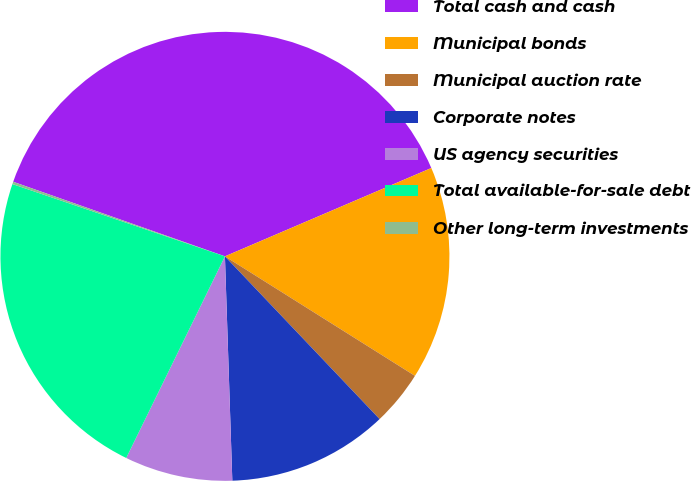Convert chart. <chart><loc_0><loc_0><loc_500><loc_500><pie_chart><fcel>Total cash and cash<fcel>Municipal bonds<fcel>Municipal auction rate<fcel>Corporate notes<fcel>US agency securities<fcel>Total available-for-sale debt<fcel>Other long-term investments<nl><fcel>38.17%<fcel>15.37%<fcel>3.97%<fcel>11.57%<fcel>7.77%<fcel>22.97%<fcel>0.17%<nl></chart> 